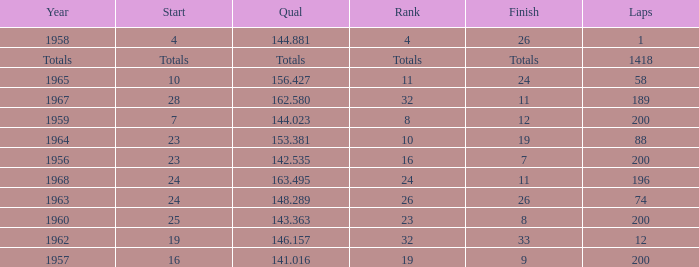What is the highest number of laps that also has a finish total of 8? 200.0. 